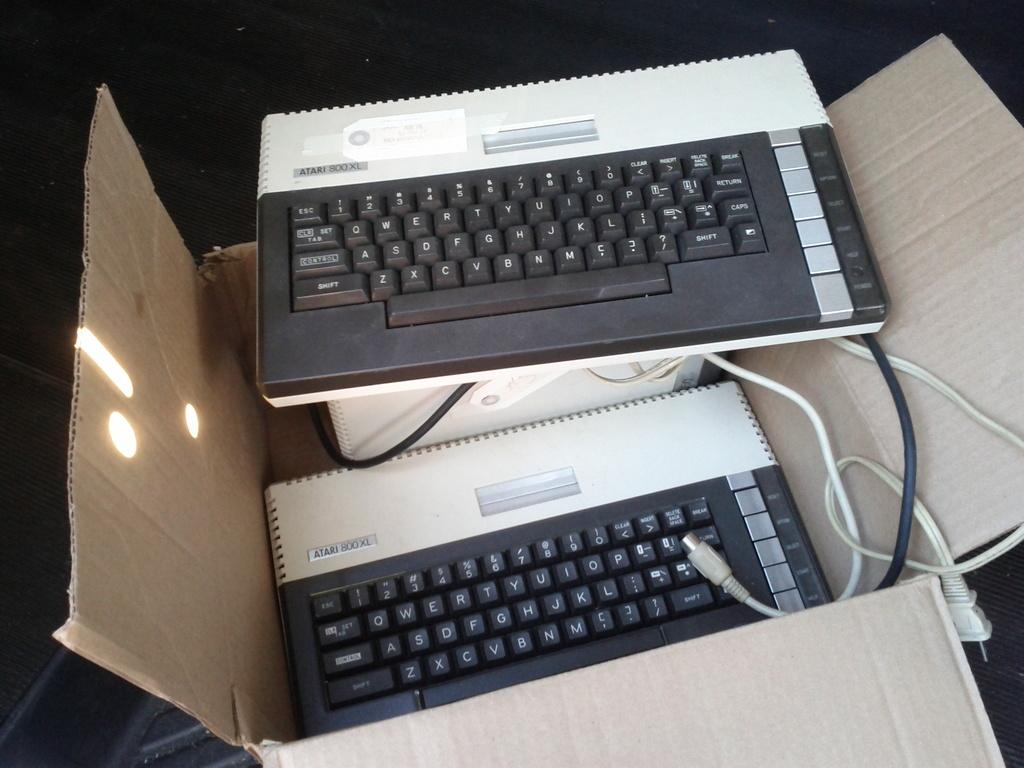What is the brand of the keyboards?
Make the answer very short. Atari. 